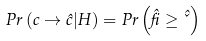Convert formula to latex. <formula><loc_0><loc_0><loc_500><loc_500>P r \left ( c \rightarrow \hat { c } | H \right ) = P r \left ( \hat { \beta } \geq \hat { \kappa } \right )</formula> 